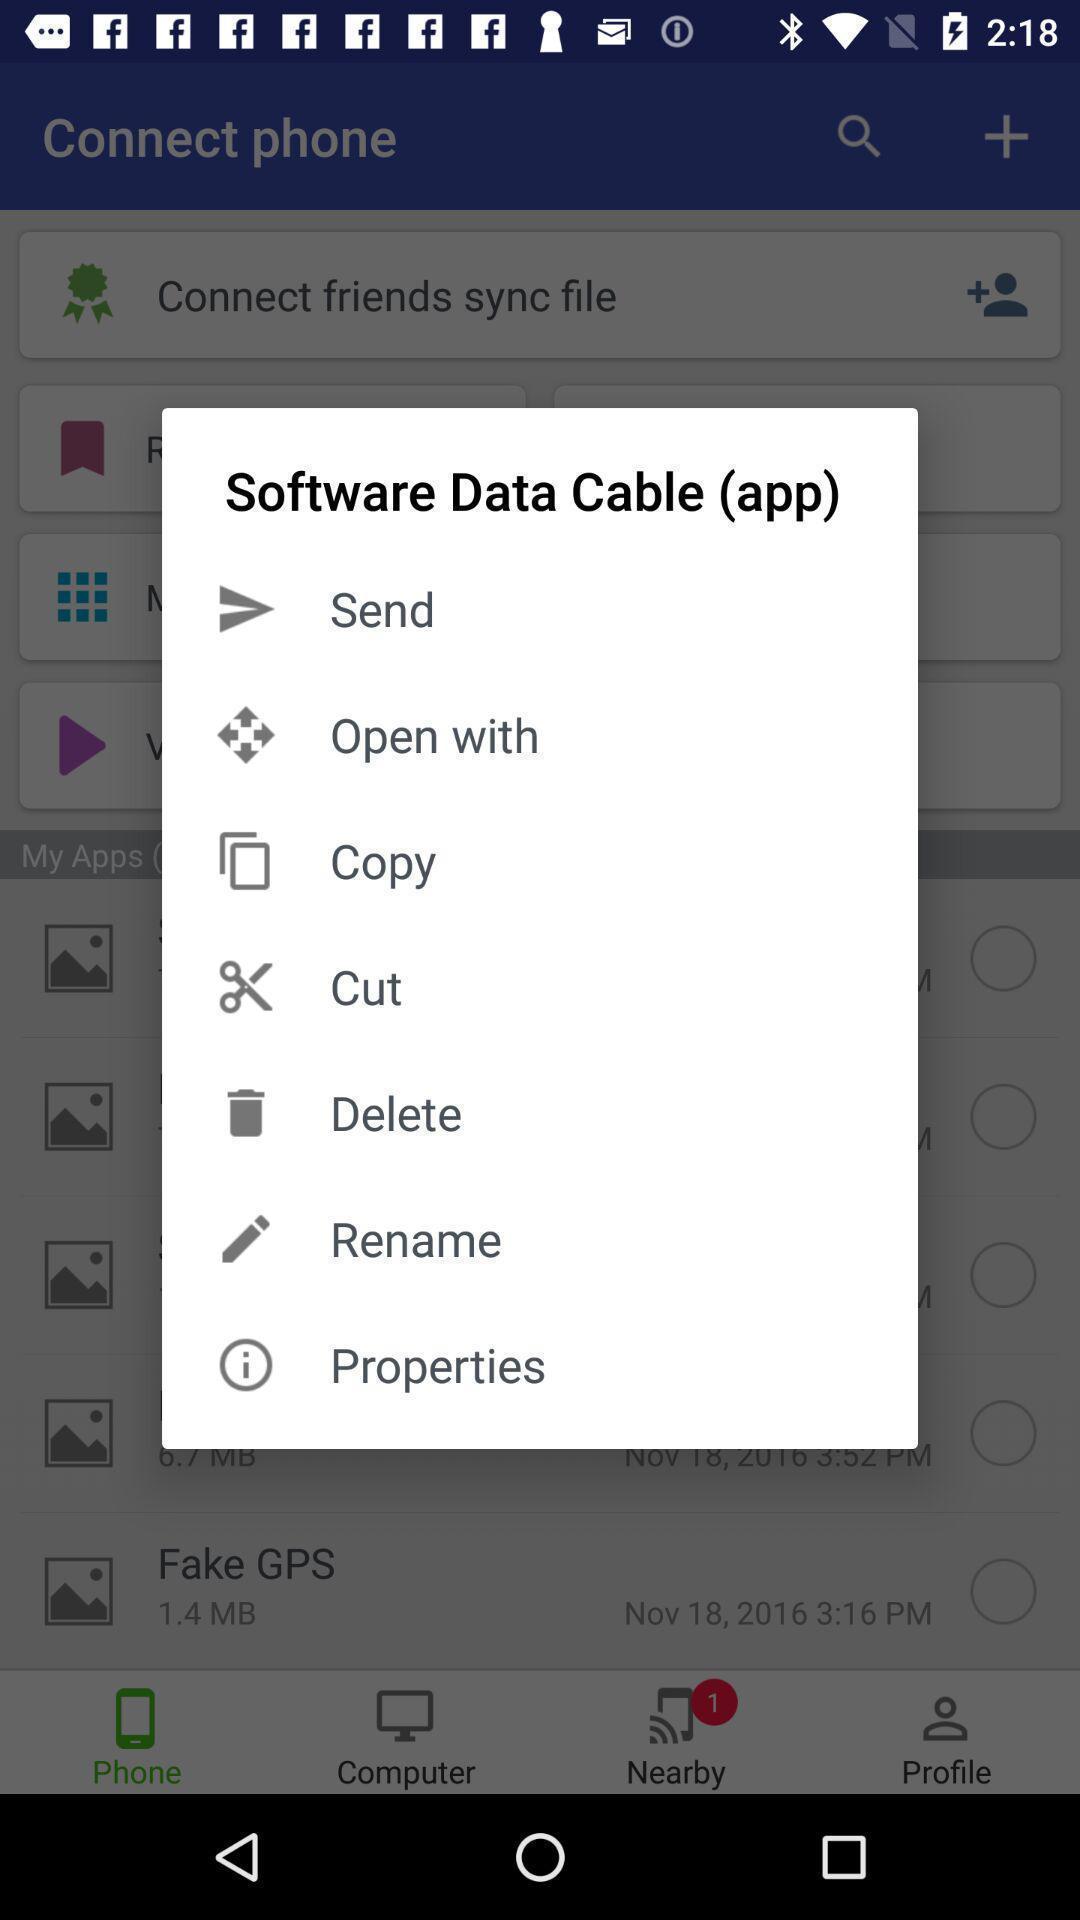Please provide a description for this image. Popup in the remote connectivity app. 